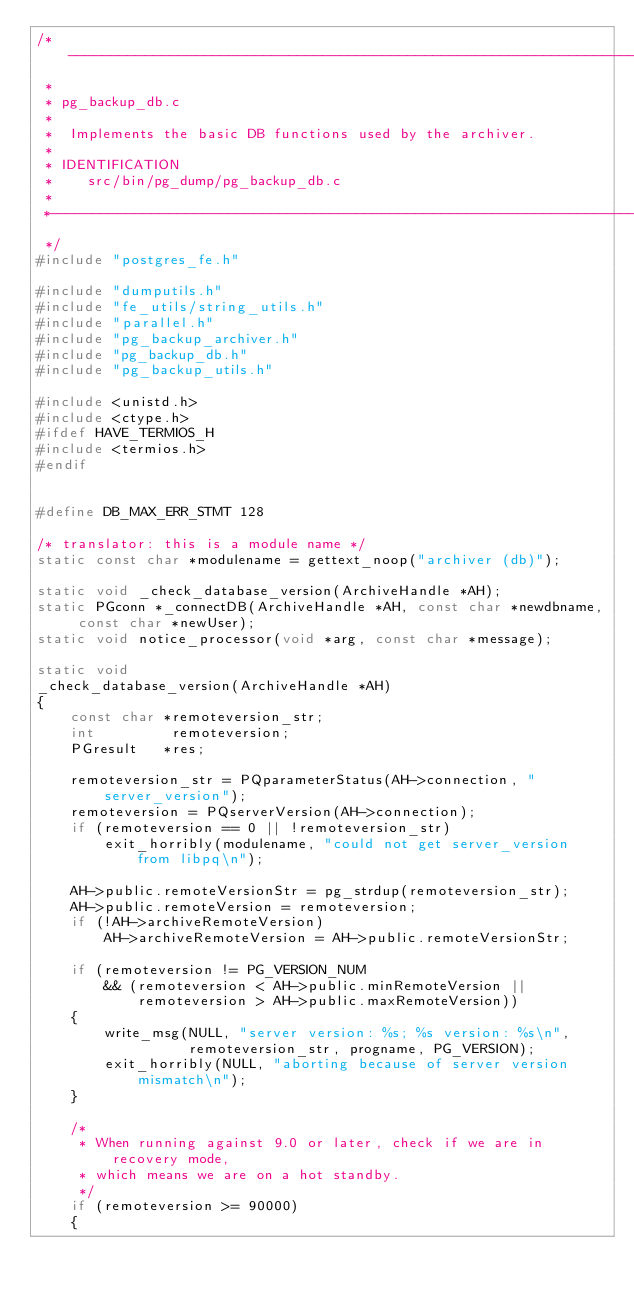<code> <loc_0><loc_0><loc_500><loc_500><_C_>/*-------------------------------------------------------------------------
 *
 * pg_backup_db.c
 *
 *	Implements the basic DB functions used by the archiver.
 *
 * IDENTIFICATION
 *	  src/bin/pg_dump/pg_backup_db.c
 *
 *-------------------------------------------------------------------------
 */
#include "postgres_fe.h"

#include "dumputils.h"
#include "fe_utils/string_utils.h"
#include "parallel.h"
#include "pg_backup_archiver.h"
#include "pg_backup_db.h"
#include "pg_backup_utils.h"

#include <unistd.h>
#include <ctype.h>
#ifdef HAVE_TERMIOS_H
#include <termios.h>
#endif


#define DB_MAX_ERR_STMT 128

/* translator: this is a module name */
static const char *modulename = gettext_noop("archiver (db)");

static void _check_database_version(ArchiveHandle *AH);
static PGconn *_connectDB(ArchiveHandle *AH, const char *newdbname, const char *newUser);
static void notice_processor(void *arg, const char *message);

static void
_check_database_version(ArchiveHandle *AH)
{
	const char *remoteversion_str;
	int			remoteversion;
	PGresult   *res;

	remoteversion_str = PQparameterStatus(AH->connection, "server_version");
	remoteversion = PQserverVersion(AH->connection);
	if (remoteversion == 0 || !remoteversion_str)
		exit_horribly(modulename, "could not get server_version from libpq\n");

	AH->public.remoteVersionStr = pg_strdup(remoteversion_str);
	AH->public.remoteVersion = remoteversion;
	if (!AH->archiveRemoteVersion)
		AH->archiveRemoteVersion = AH->public.remoteVersionStr;

	if (remoteversion != PG_VERSION_NUM
		&& (remoteversion < AH->public.minRemoteVersion ||
			remoteversion > AH->public.maxRemoteVersion))
	{
		write_msg(NULL, "server version: %s; %s version: %s\n",
				  remoteversion_str, progname, PG_VERSION);
		exit_horribly(NULL, "aborting because of server version mismatch\n");
	}

	/*
	 * When running against 9.0 or later, check if we are in recovery mode,
	 * which means we are on a hot standby.
	 */
	if (remoteversion >= 90000)
	{</code> 